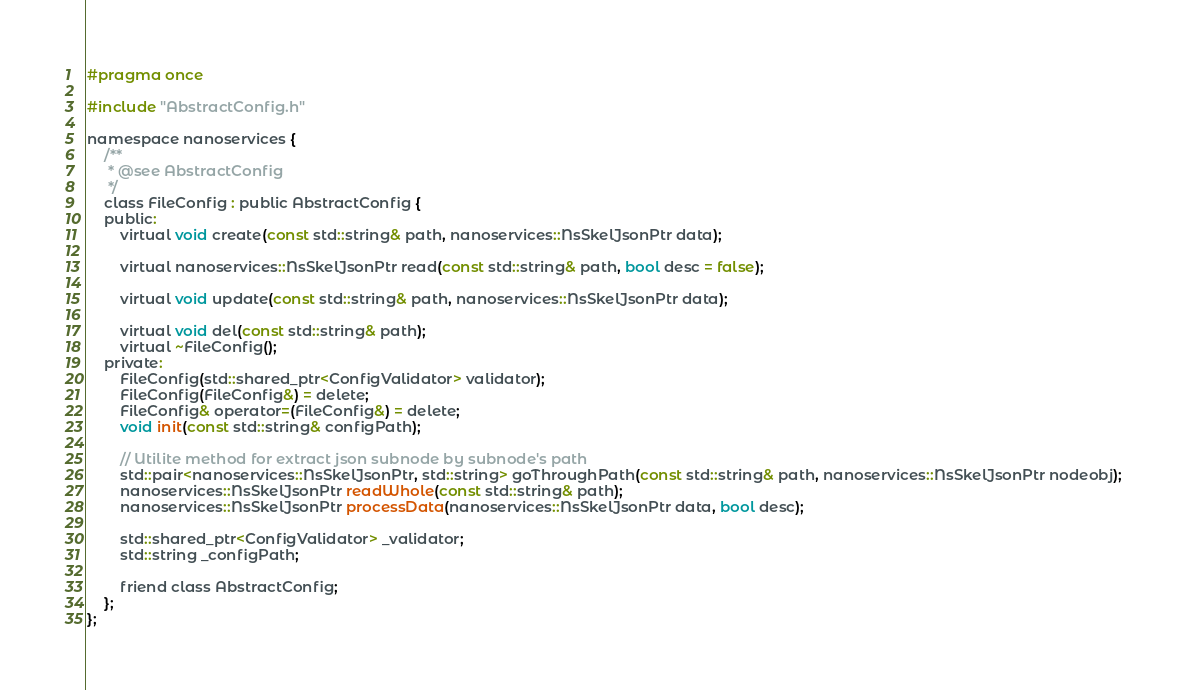Convert code to text. <code><loc_0><loc_0><loc_500><loc_500><_C_>#pragma once

#include "AbstractConfig.h"

namespace nanoservices {
	/**
	 * @see AbstractConfig
	 */
	class FileConfig : public AbstractConfig {
	public:
		virtual void create(const std::string& path, nanoservices::NsSkelJsonPtr data);
		
		virtual nanoservices::NsSkelJsonPtr read(const std::string& path, bool desc = false);
		
		virtual void update(const std::string& path, nanoservices::NsSkelJsonPtr data);
		
		virtual void del(const std::string& path);
		virtual ~FileConfig();
	private:
		FileConfig(std::shared_ptr<ConfigValidator> validator);
		FileConfig(FileConfig&) = delete;
		FileConfig& operator=(FileConfig&) = delete;
		void init(const std::string& configPath);

		// Utilite method for extract json subnode by subnode's path
		std::pair<nanoservices::NsSkelJsonPtr, std::string> goThroughPath(const std::string& path, nanoservices::NsSkelJsonPtr nodeobj);
		nanoservices::NsSkelJsonPtr readWhole(const std::string& path);
		nanoservices::NsSkelJsonPtr processData(nanoservices::NsSkelJsonPtr data, bool desc);

		std::shared_ptr<ConfigValidator> _validator;
		std::string _configPath;

		friend class AbstractConfig;
	};
};
</code> 